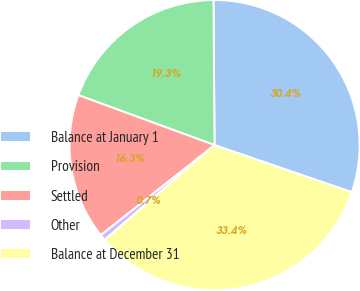<chart> <loc_0><loc_0><loc_500><loc_500><pie_chart><fcel>Balance at January 1<fcel>Provision<fcel>Settled<fcel>Other<fcel>Balance at December 31<nl><fcel>30.38%<fcel>19.29%<fcel>16.26%<fcel>0.66%<fcel>33.42%<nl></chart> 